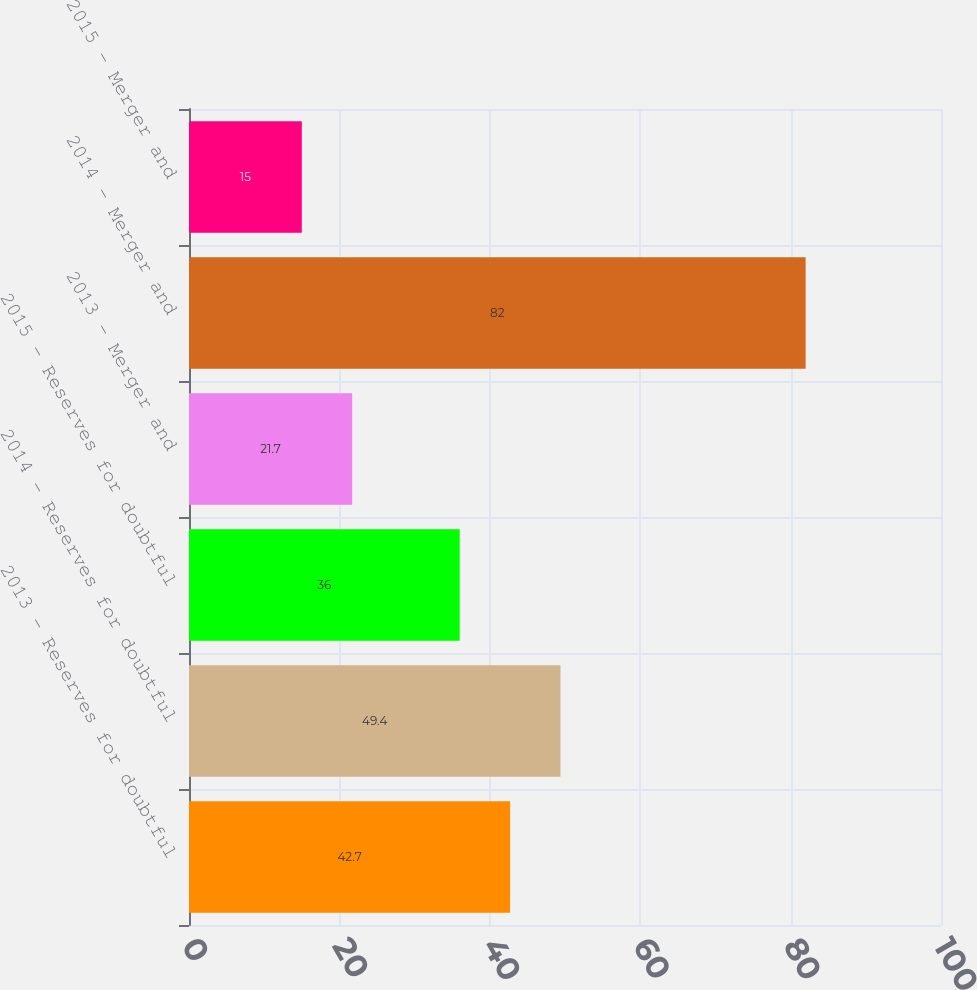Convert chart. <chart><loc_0><loc_0><loc_500><loc_500><bar_chart><fcel>2013 - Reserves for doubtful<fcel>2014 - Reserves for doubtful<fcel>2015 - Reserves for doubtful<fcel>2013 - Merger and<fcel>2014 - Merger and<fcel>2015 - Merger and<nl><fcel>42.7<fcel>49.4<fcel>36<fcel>21.7<fcel>82<fcel>15<nl></chart> 